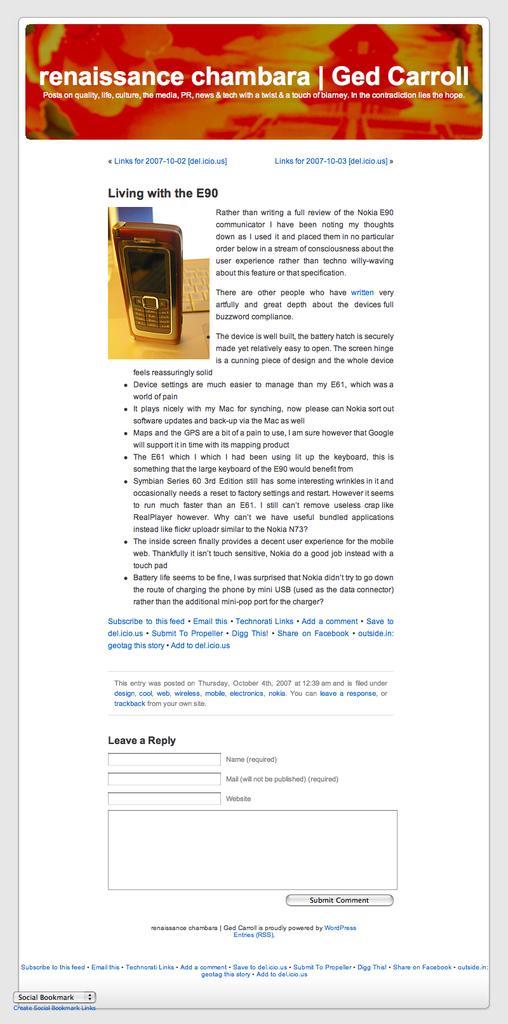In one or two sentences, can you explain what this image depicts? In this image we can see some text on the screen and also a mobile phone. 